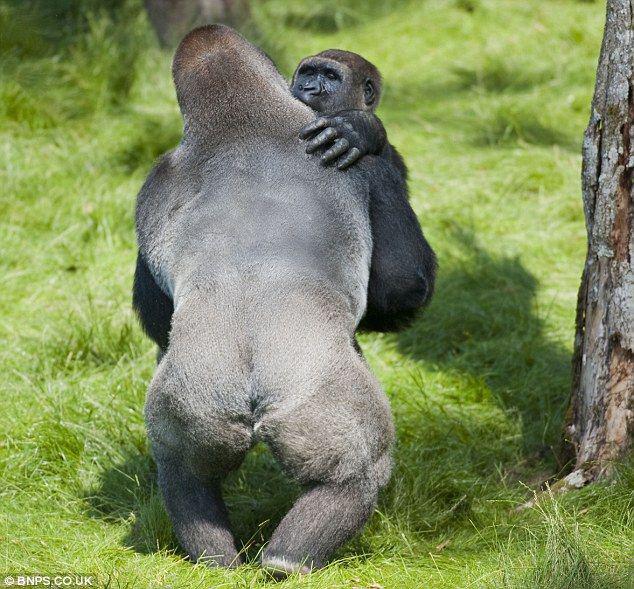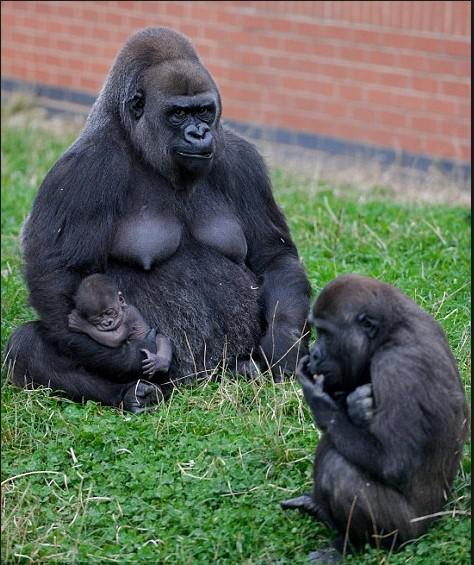The first image is the image on the left, the second image is the image on the right. For the images shown, is this caption "The left image shows a back-turned adult gorilla with a hump-shaped head standing upright and face-to-face with one other gorilla." true? Answer yes or no. Yes. 